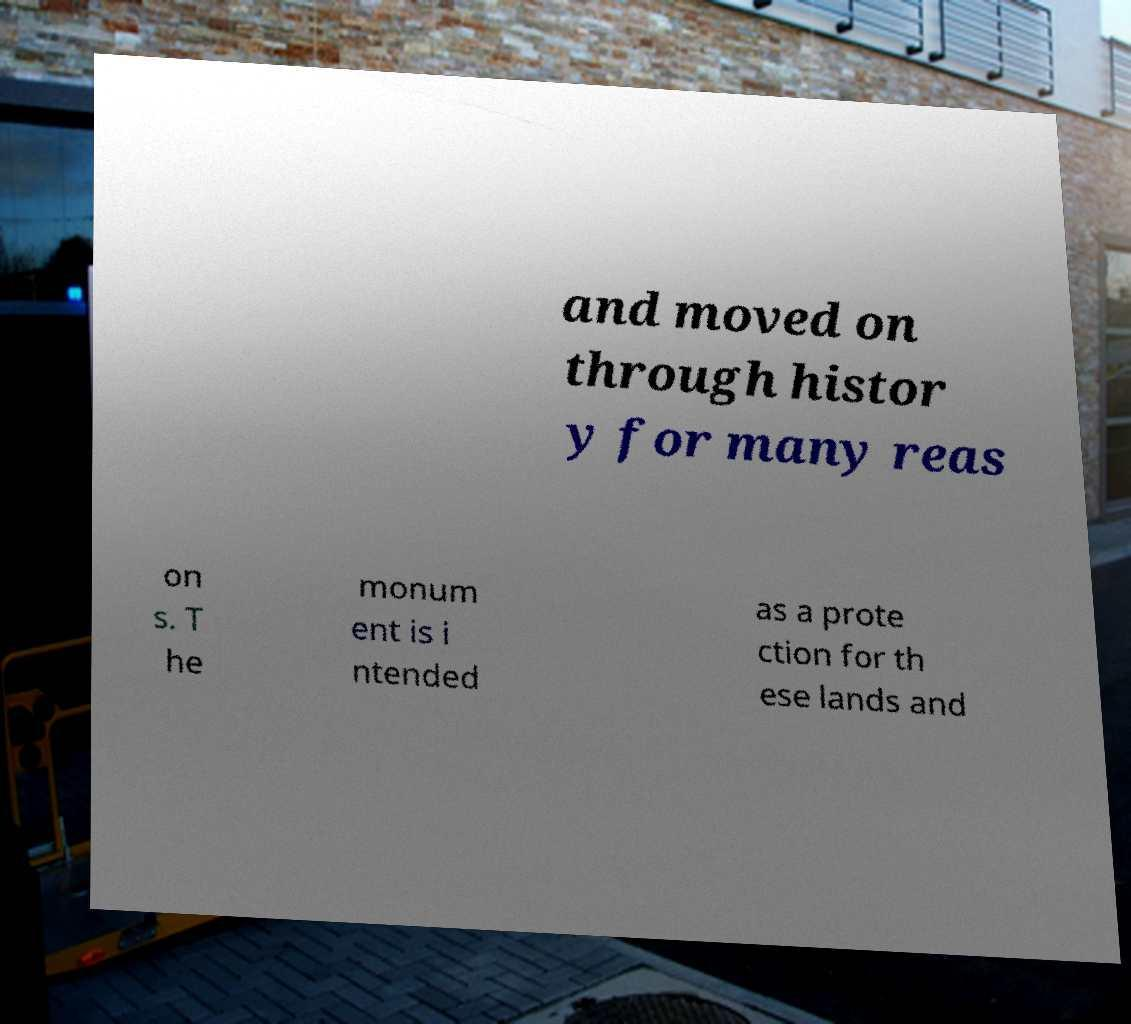Could you assist in decoding the text presented in this image and type it out clearly? and moved on through histor y for many reas on s. T he monum ent is i ntended as a prote ction for th ese lands and 